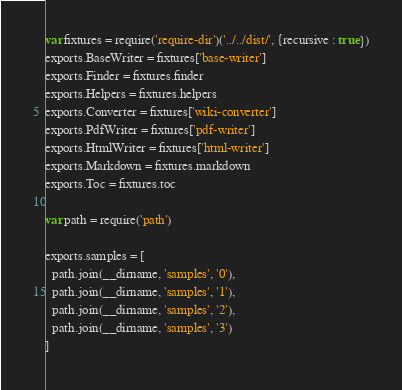Convert code to text. <code><loc_0><loc_0><loc_500><loc_500><_JavaScript_>var fixtures = require('require-dir')('../../dist/', {recursive : true})
exports.BaseWriter = fixtures['base-writer']
exports.Finder = fixtures.finder
exports.Helpers = fixtures.helpers
exports.Converter = fixtures['wiki-converter']
exports.PdfWriter = fixtures['pdf-writer']
exports.HtmlWriter = fixtures['html-writer']
exports.Markdown = fixtures.markdown
exports.Toc = fixtures.toc

var path = require('path')

exports.samples = [
  path.join(__dirname, 'samples', '0'),
  path.join(__dirname, 'samples', '1'),
  path.join(__dirname, 'samples', '2'),
  path.join(__dirname, 'samples', '3')
]
</code> 